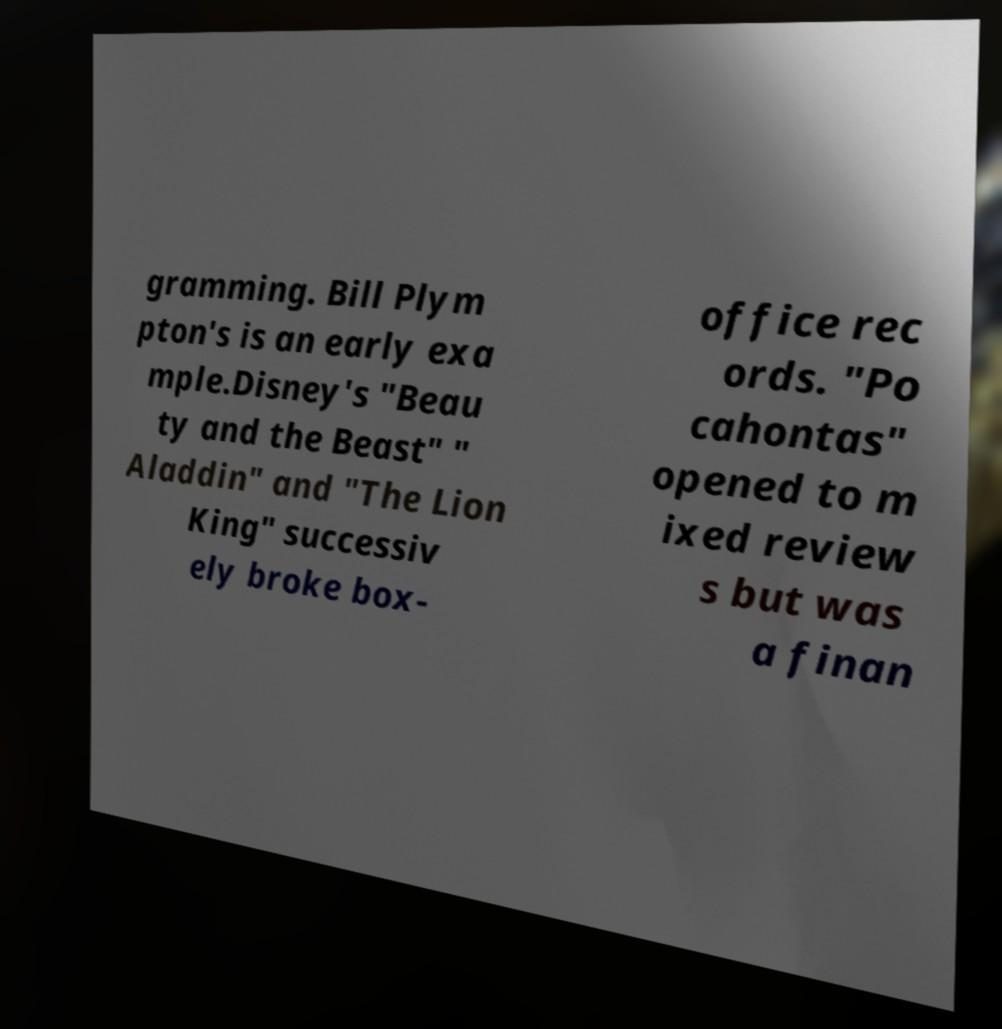Can you accurately transcribe the text from the provided image for me? gramming. Bill Plym pton's is an early exa mple.Disney's "Beau ty and the Beast" " Aladdin" and "The Lion King" successiv ely broke box- office rec ords. "Po cahontas" opened to m ixed review s but was a finan 